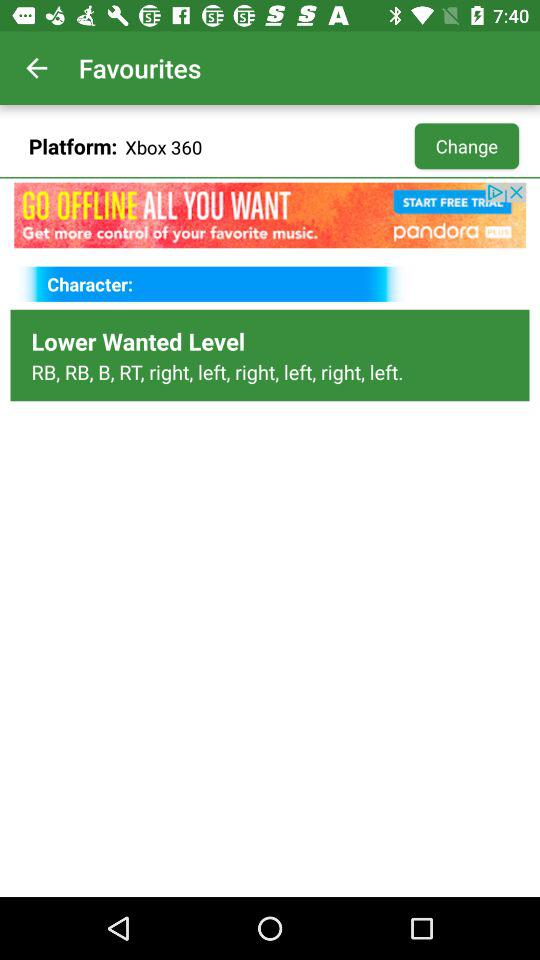What are the lower wanted levels for Xbox 360? The lower wanted levels are RB, RB, B, RT, right, left, right, left, right and left. 